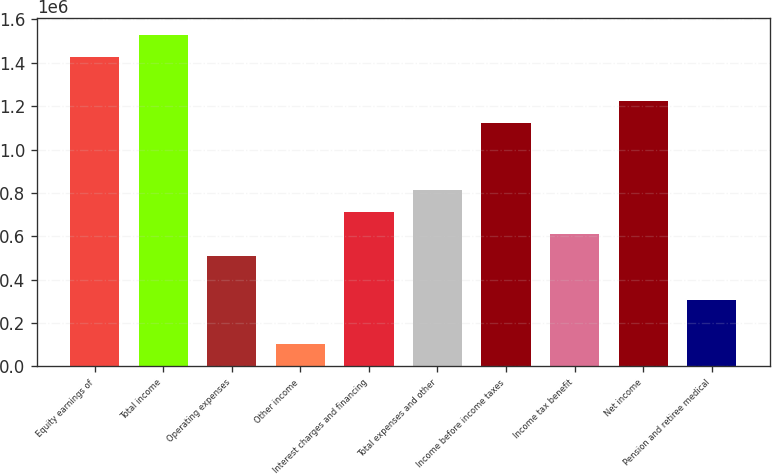Convert chart. <chart><loc_0><loc_0><loc_500><loc_500><bar_chart><fcel>Equity earnings of<fcel>Total income<fcel>Operating expenses<fcel>Other income<fcel>Interest charges and financing<fcel>Total expenses and other<fcel>Income before income taxes<fcel>Income tax benefit<fcel>Net income<fcel>Pension and retiree medical<nl><fcel>1.4263e+06<fcel>1.52817e+06<fcel>509392<fcel>101879<fcel>713148<fcel>815027<fcel>1.12066e+06<fcel>611270<fcel>1.22254e+06<fcel>305636<nl></chart> 